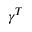Convert formula to latex. <formula><loc_0><loc_0><loc_500><loc_500>\gamma ^ { T }</formula> 